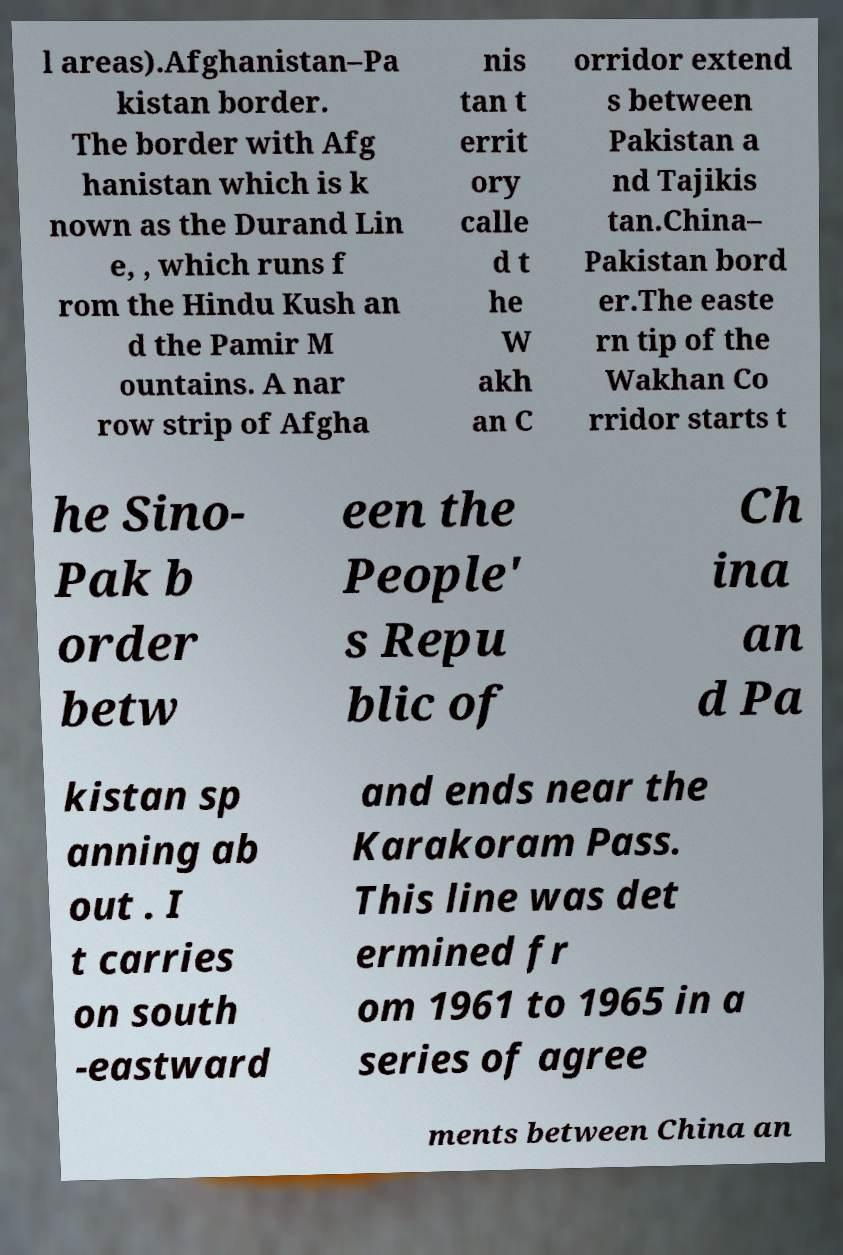There's text embedded in this image that I need extracted. Can you transcribe it verbatim? l areas).Afghanistan–Pa kistan border. The border with Afg hanistan which is k nown as the Durand Lin e, , which runs f rom the Hindu Kush an d the Pamir M ountains. A nar row strip of Afgha nis tan t errit ory calle d t he W akh an C orridor extend s between Pakistan a nd Tajikis tan.China– Pakistan bord er.The easte rn tip of the Wakhan Co rridor starts t he Sino- Pak b order betw een the People' s Repu blic of Ch ina an d Pa kistan sp anning ab out . I t carries on south -eastward and ends near the Karakoram Pass. This line was det ermined fr om 1961 to 1965 in a series of agree ments between China an 